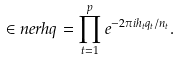Convert formula to latex. <formula><loc_0><loc_0><loc_500><loc_500>\in n e r { h } { q } = \prod _ { t = 1 } ^ { p } e ^ { - 2 \pi i h _ { t } q _ { t } / n _ { t } } .</formula> 